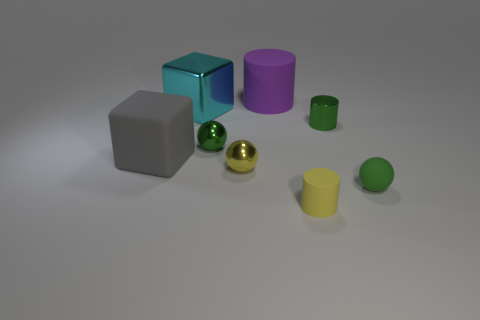There is a gray object; is it the same shape as the cyan thing behind the tiny yellow matte object?
Make the answer very short. Yes. There is a yellow thing that is made of the same material as the tiny green cylinder; what is its shape?
Give a very brief answer. Sphere. Is the number of spheres that are on the right side of the yellow sphere greater than the number of small yellow metallic objects behind the purple matte cylinder?
Your response must be concise. Yes. How many things are either matte cubes or tiny purple matte balls?
Provide a short and direct response. 1. How many other things are the same color as the big matte cylinder?
Your answer should be compact. 0. What shape is the other yellow thing that is the same size as the yellow metal thing?
Keep it short and to the point. Cylinder. What is the color of the metal object that is to the right of the purple cylinder?
Provide a short and direct response. Green. What number of objects are either shiny things that are left of the purple cylinder or metal things on the left side of the large purple rubber cylinder?
Give a very brief answer. 3. Does the cyan metal block have the same size as the yellow shiny ball?
Provide a short and direct response. No. How many cubes are either large gray objects or big cyan metal objects?
Provide a succinct answer. 2. 